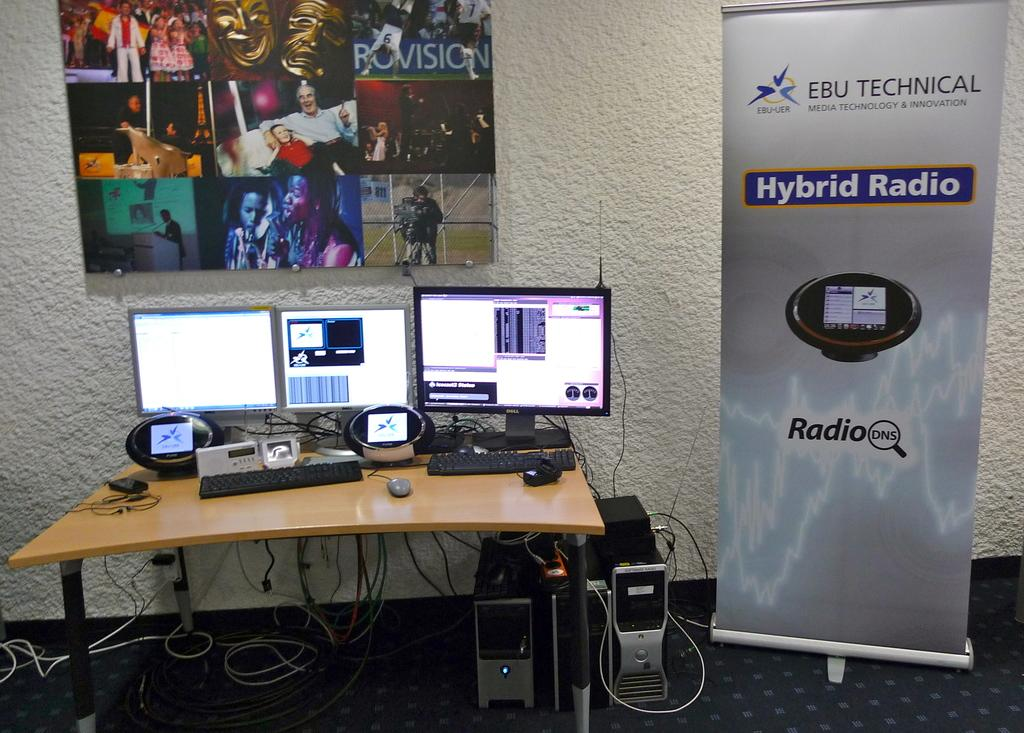<image>
Share a concise interpretation of the image provided. Hybrid Radio advertisement next to some computers on the desk 